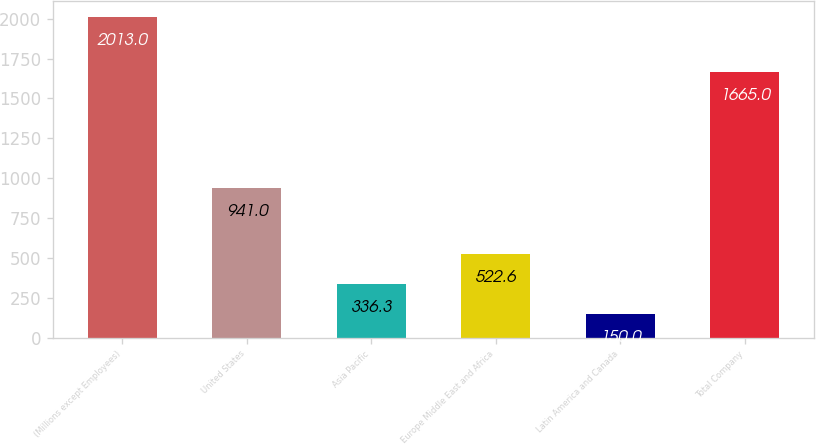Convert chart to OTSL. <chart><loc_0><loc_0><loc_500><loc_500><bar_chart><fcel>(Millions except Employees)<fcel>United States<fcel>Asia Pacific<fcel>Europe Middle East and Africa<fcel>Latin America and Canada<fcel>Total Company<nl><fcel>2013<fcel>941<fcel>336.3<fcel>522.6<fcel>150<fcel>1665<nl></chart> 